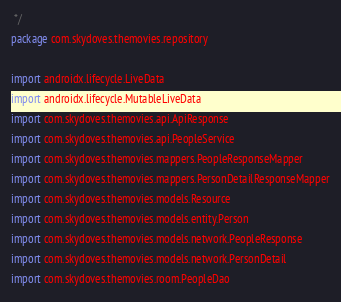Convert code to text. <code><loc_0><loc_0><loc_500><loc_500><_Kotlin_> */
package com.skydoves.themovies.repository

import androidx.lifecycle.LiveData
import androidx.lifecycle.MutableLiveData
import com.skydoves.themovies.api.ApiResponse
import com.skydoves.themovies.api.PeopleService
import com.skydoves.themovies.mappers.PeopleResponseMapper
import com.skydoves.themovies.mappers.PersonDetailResponseMapper
import com.skydoves.themovies.models.Resource
import com.skydoves.themovies.models.entity.Person
import com.skydoves.themovies.models.network.PeopleResponse
import com.skydoves.themovies.models.network.PersonDetail
import com.skydoves.themovies.room.PeopleDao</code> 